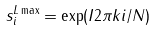<formula> <loc_0><loc_0><loc_500><loc_500>s ^ { L \max } _ { i } = \exp ( I 2 \pi k i / N )</formula> 